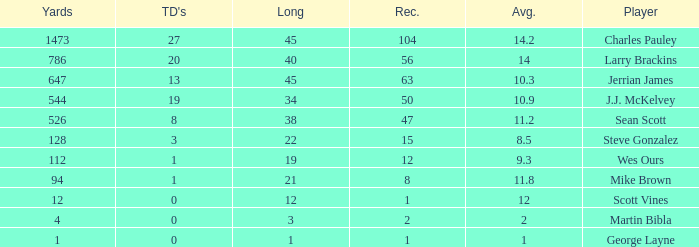How many receptions for players with over 647 yards and an under 14 yard average? None. 